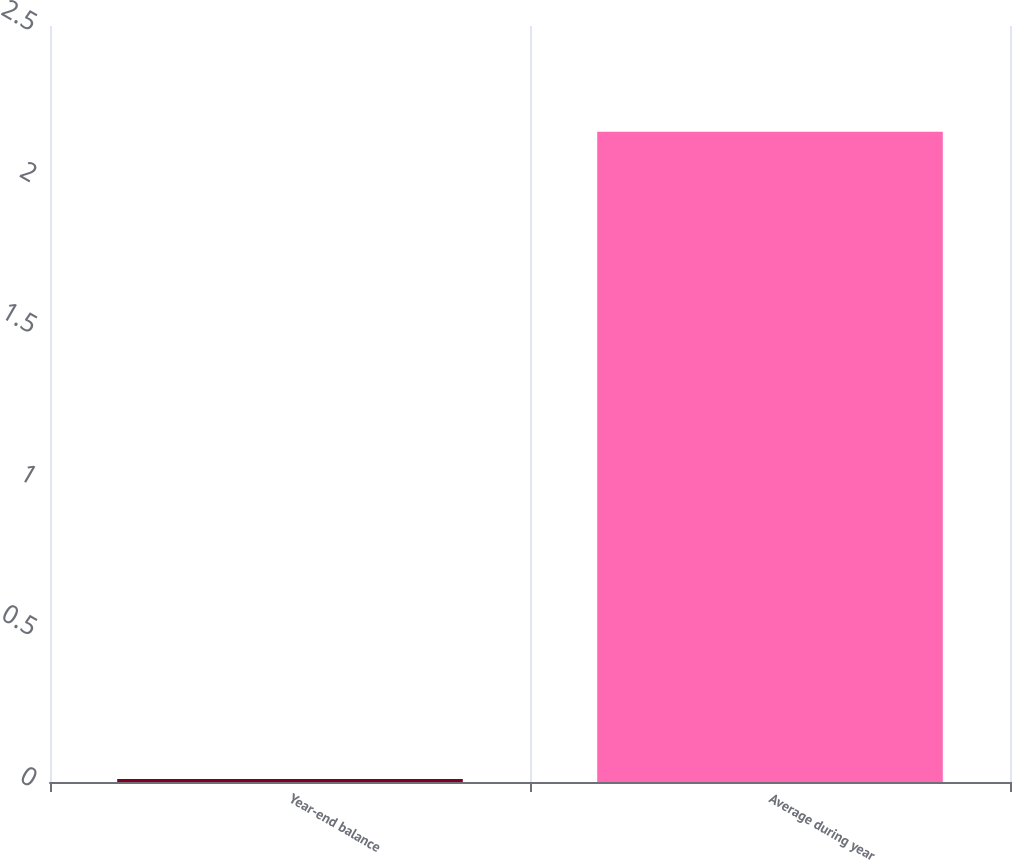Convert chart to OTSL. <chart><loc_0><loc_0><loc_500><loc_500><bar_chart><fcel>Year-end balance<fcel>Average during year<nl><fcel>0.01<fcel>2.15<nl></chart> 